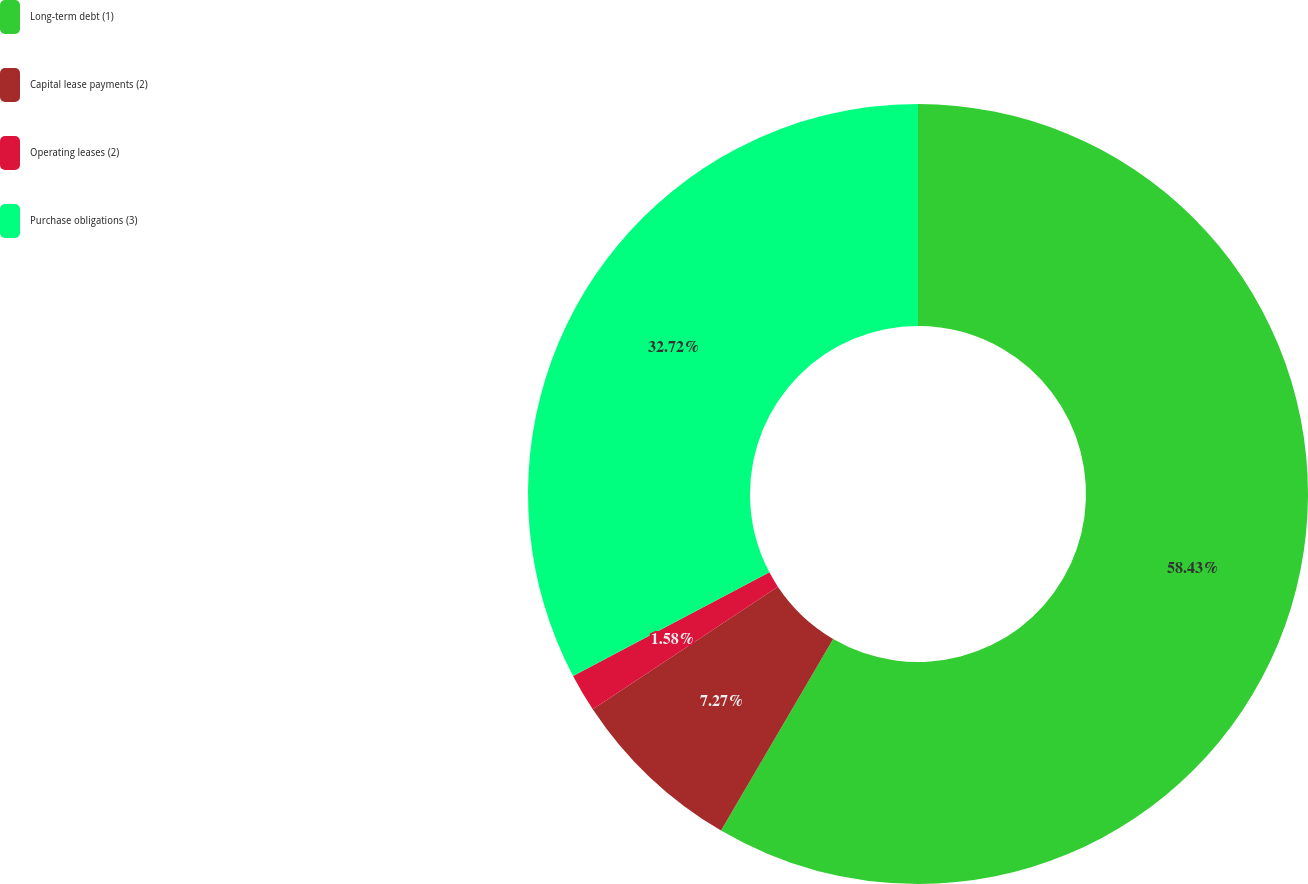Convert chart to OTSL. <chart><loc_0><loc_0><loc_500><loc_500><pie_chart><fcel>Long-term debt (1)<fcel>Capital lease payments (2)<fcel>Operating leases (2)<fcel>Purchase obligations (3)<nl><fcel>58.42%<fcel>7.27%<fcel>1.58%<fcel>32.72%<nl></chart> 